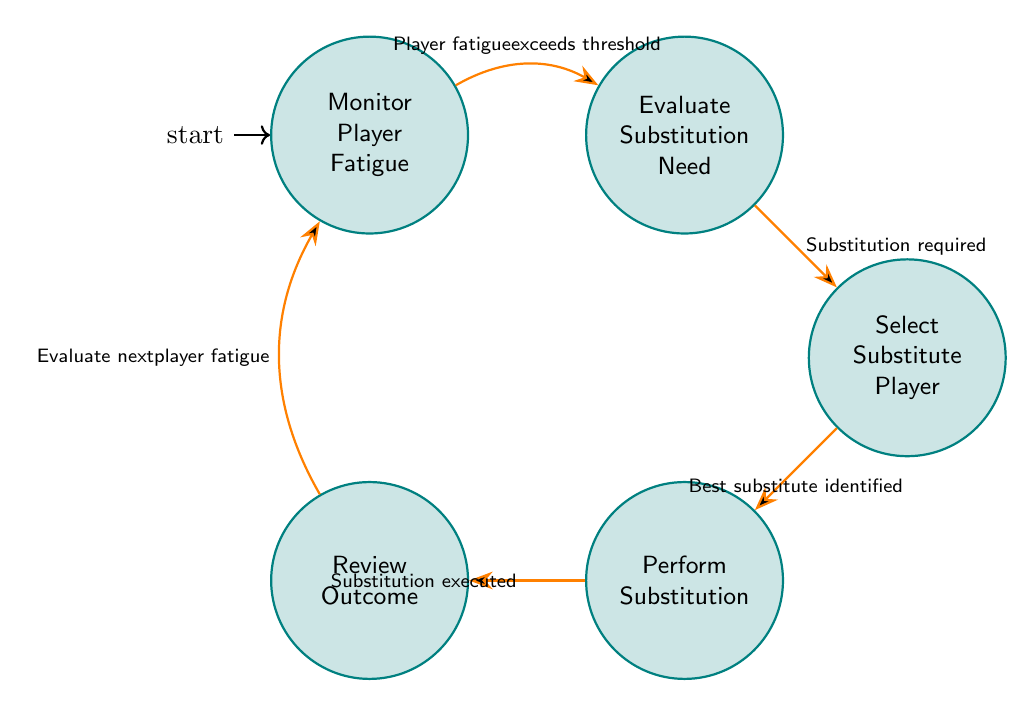What is the starting state of the diagram? The starting state is indicated by the initial node label that shows where the process begins. In this case, it is labeled "Monitor Player Fatigue."
Answer: Monitor Player Fatigue How many states are in the diagram? The number of states is determined by counting the individual nodes present in the diagram. There are five states: "Monitor Player Fatigue," "Evaluate Substitution Need," "Select Substitute Player," "Perform Substitution," and "Review Outcome."
Answer: 5 What action is performed in the "Select Substitute Player" state? Each state has specific actions associated with it. For the "Select Substitute Player" state, the actions listed are "Identify optimal replacements," "Check substitute readiness," and "Analyze positional requirements."
Answer: Identify optimal replacements, Check substitute readiness, Analyze positional requirements What is the condition to transition from "Evaluate Substitution Need" to "Select Substitute Player"? The transition condition is indicated by the label on the edge connecting the two states. The condition for this transition is "Substitution required."
Answer: Substitution required Which state follows "Perform Substitution"? This can be determined by looking at the transition from the state "Perform Substitution." According to the diagram, the next state is "Review Outcome."
Answer: Review Outcome What causes the transition from "Review Outcome" back to "Monitor Player Fatigue"? The transition between states is defined by certain conditions. Here, the condition for moving back to "Monitor Player Fatigue" is "Evaluate next player fatigue."
Answer: Evaluate next player fatigue What is the first action in the "Evaluate Substitution Need" state? Each state has a specific set of actions, and the first action in the "Evaluate Substitution Need" state is "Compare fatigue against thresholds."
Answer: Compare fatigue against thresholds What happens if the "Player fatigue exceeds threshold" condition is not met? If the condition "Player fatigue exceeds threshold" is not met, the system remains in the "Monitor Player Fatigue" state, as there is no transition indicated. The monitoring continues without proceeding to the next state.
Answer: Remain in "Monitor Player Fatigue" What is the last action in the "Perform Substitution" state? Each state has actions that occur during that state. For "Perform Substitution," the last action listed is "Communicate strategy changes."
Answer: Communicate strategy changes 